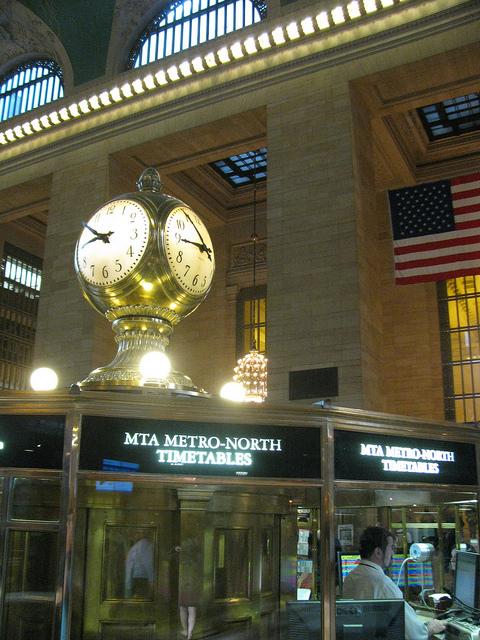Can you see people in the picture?
Short answer required. Yes. What time is it?
Be succinct. 8:50. Is this a railway station?
Give a very brief answer. Yes. 